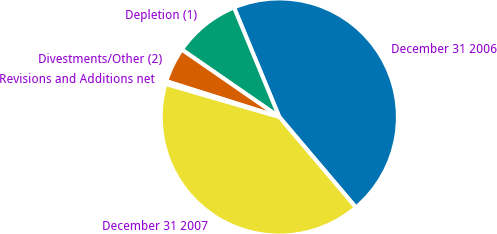Convert chart to OTSL. <chart><loc_0><loc_0><loc_500><loc_500><pie_chart><fcel>December 31 2006<fcel>Depletion (1)<fcel>Divestments/Other (2)<fcel>Revisions and Additions net<fcel>December 31 2007<nl><fcel>45.06%<fcel>9.13%<fcel>4.75%<fcel>0.38%<fcel>40.68%<nl></chart> 